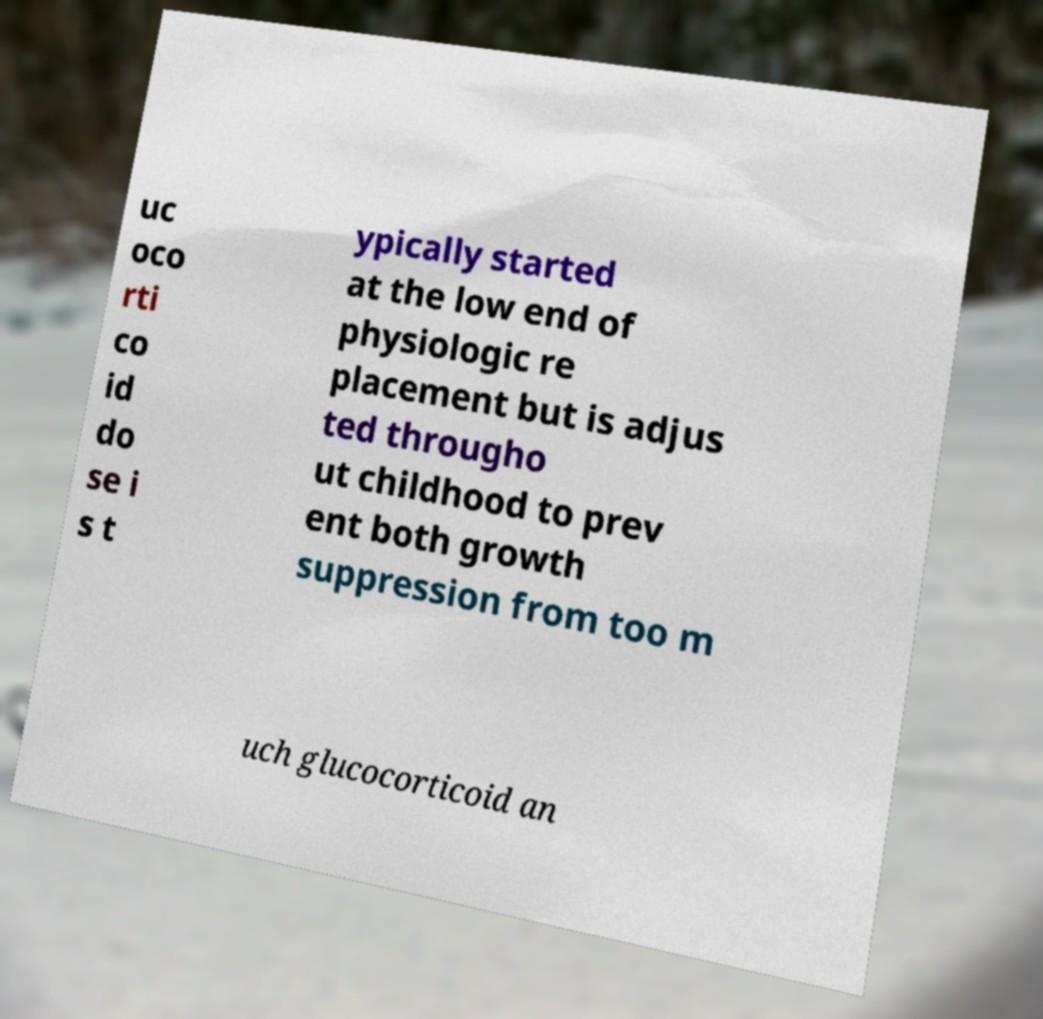For documentation purposes, I need the text within this image transcribed. Could you provide that? uc oco rti co id do se i s t ypically started at the low end of physiologic re placement but is adjus ted througho ut childhood to prev ent both growth suppression from too m uch glucocorticoid an 